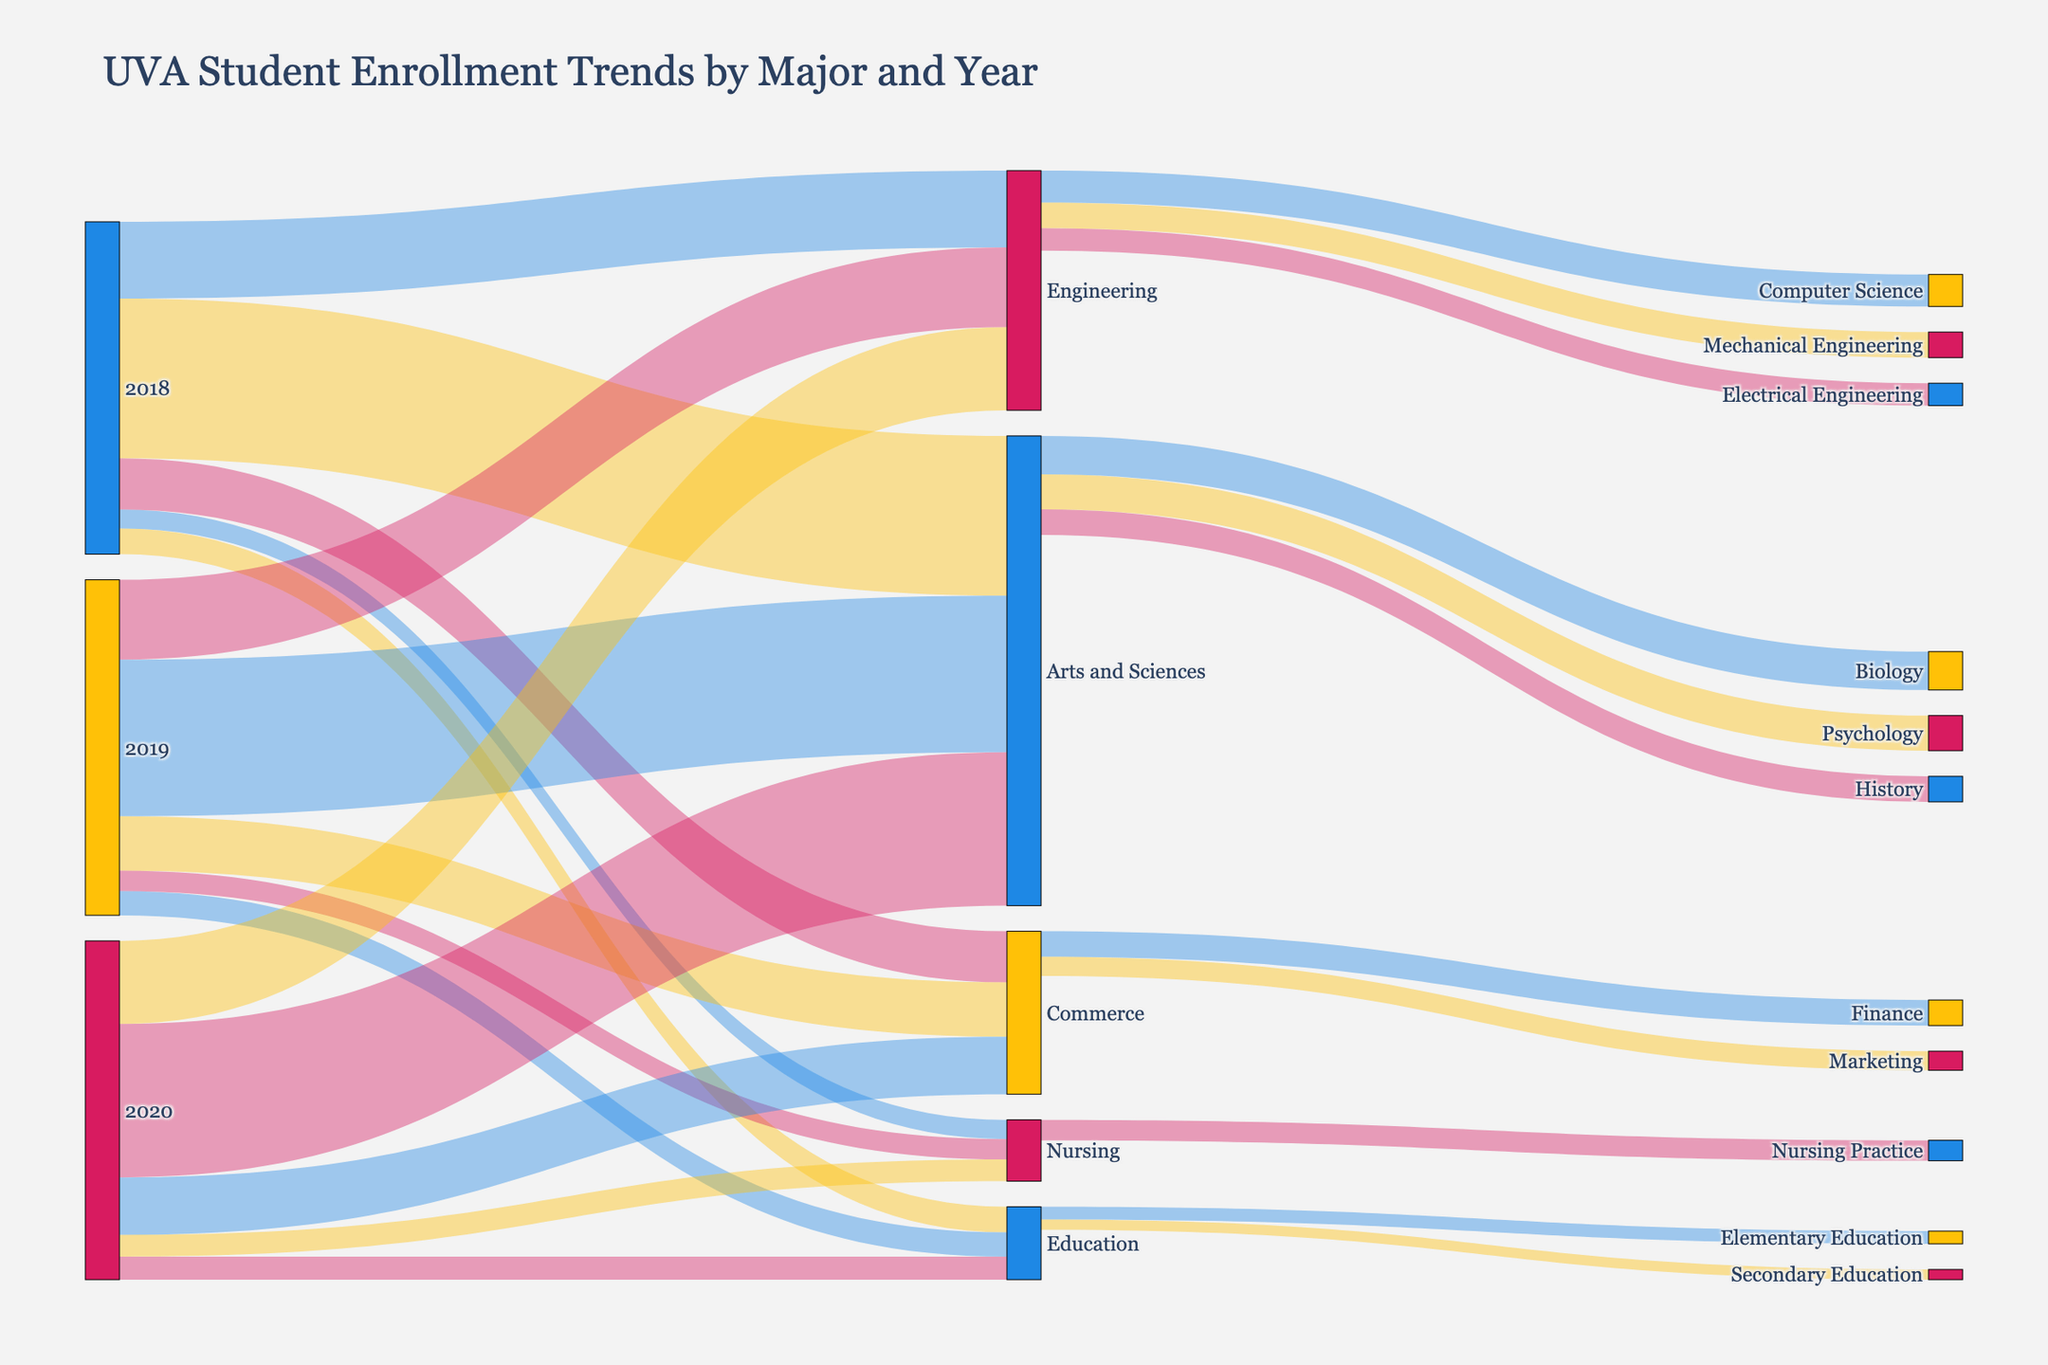What is the title of the figure? The title is usually displayed prominently at the top of the figure. In this case, it reads "UVA Student Enrollment Trends by Major and Year".
Answer: UVA Student Enrollment Trends by Major and Year How many students enrolled in the Engineering major in 2020? Locate the section of the Sankey diagram that connects the year 2020 to the Engineering major and read the corresponding value.
Answer: 1300 Which major had the highest enrollment in 2019? Identify the different values connected to the year 2019 in the Sankey diagram and compare them. The highest value corresponds to the Arts and Sciences major.
Answer: Arts and Sciences What is the sum of students enrolled in Commerce from 2018 to 2020? First, collect the enrollment values for Commerce from 2018 to 2020: 800 (2018), 850 (2019), and 900 (2020). Then, sum these values: 800 + 850 + 900 = 2550.
Answer: 2550 Compare the enrollment trends of Arts and Sciences and Engineering majors from 2018 to 2020. Which major saw a decrease and which saw an increase? Examine the values for Arts and Sciences and Engineering from 2018 to 2020. Arts and Sciences starts at 2500 in 2018 and decreases to 2400 in 2020. Engineering starts at 1200 in 2018 and increases to 1300 in 2020.
Answer: Arts and Sciences saw a decrease; Engineering saw an increase How many students chose Computer Science within the Engineering major? Refer to the connections from the Engineering major to its sub-disciplines and find the value for Computer Science.
Answer: 500 What is the total number of students in the Nursing major across all years shown? Sum up the Nursing enrollment values from 2018 (300), 2019 (320), and 2020 (340). The total is 300 + 320 + 340 = 960.
Answer: 960 Which major under Arts and Sciences has the lowest enrollment? Look at the sub-disciplines under Arts and Sciences and compare the values. The lowest value is for History with 400 students.
Answer: History Did the total enrollment in Education increase or decrease from 2018 to 2020? Compare the values for Education in 2018 (400), 2019 (380), and 2020 (360) to determine the trend. There's a decrease from 400 in 2018 to 360 in 2020.
Answer: Decrease 